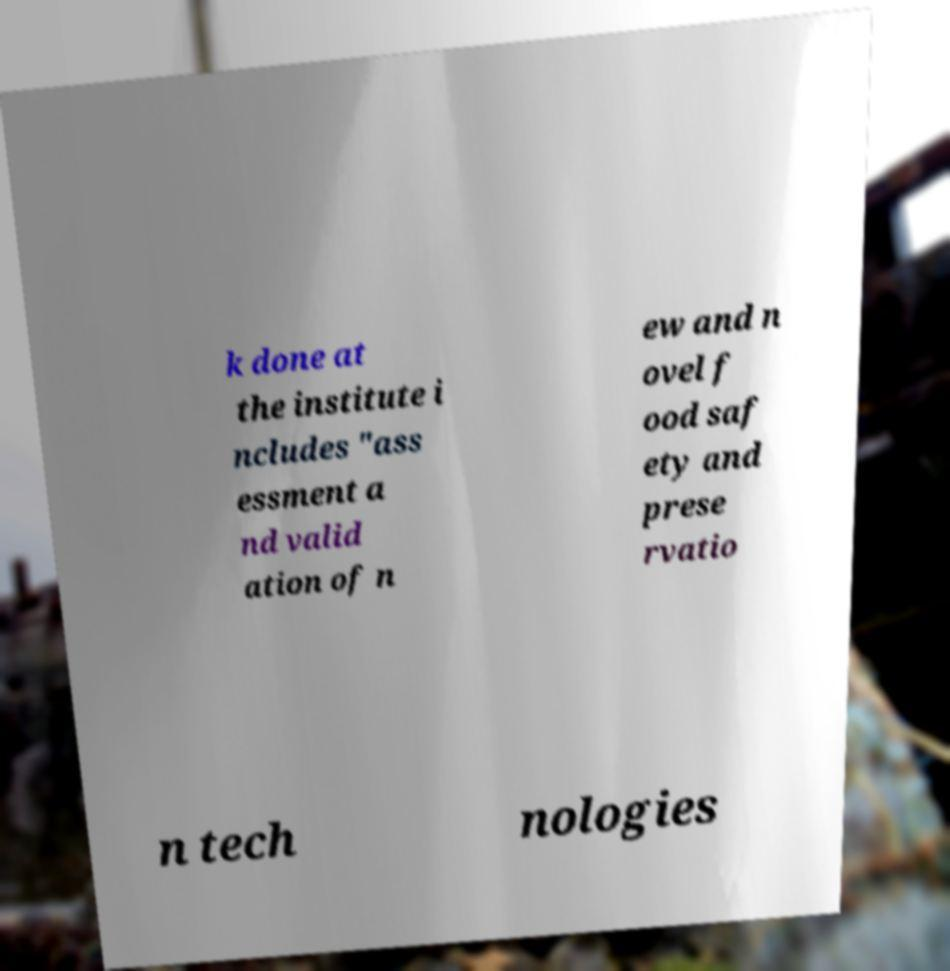Please identify and transcribe the text found in this image. k done at the institute i ncludes "ass essment a nd valid ation of n ew and n ovel f ood saf ety and prese rvatio n tech nologies 